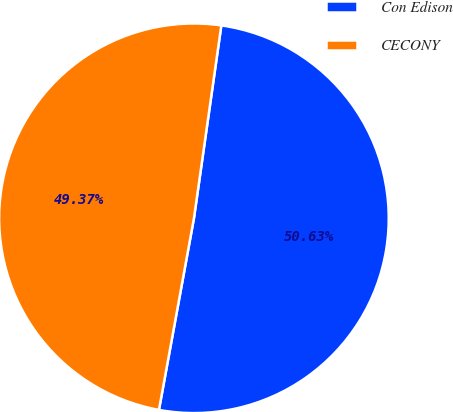Convert chart to OTSL. <chart><loc_0><loc_0><loc_500><loc_500><pie_chart><fcel>Con Edison<fcel>CECONY<nl><fcel>50.63%<fcel>49.37%<nl></chart> 